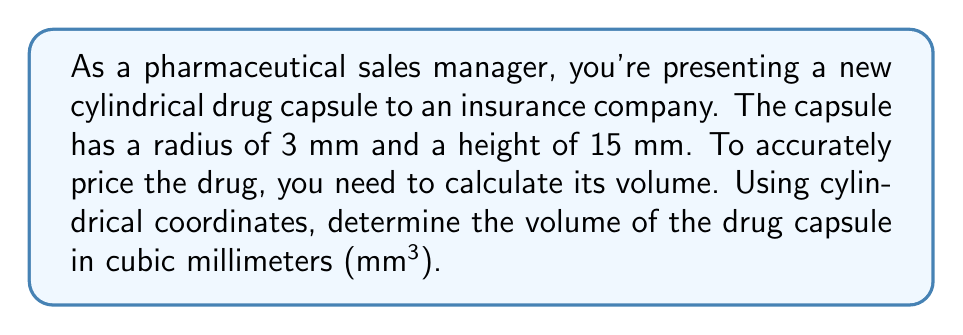Teach me how to tackle this problem. To calculate the volume of a cylindrical drug capsule using cylindrical coordinates, we'll follow these steps:

1) In cylindrical coordinates, a point is represented by $(r, \theta, z)$, where:
   - $r$ is the distance from the point to the z-axis
   - $\theta$ is the angle in the xy-plane from the positive x-axis
   - $z$ is the height above the xy-plane

2) The volume integral in cylindrical coordinates is given by:

   $$V = \iiint r \, dr \, d\theta \, dz$$

3) For our cylindrical capsule:
   - Radius (r) goes from 0 to 3 mm
   - Angle ($\theta$) goes from 0 to $2\pi$ radians
   - Height (z) goes from 0 to 15 mm

4) Set up the triple integral:

   $$V = \int_0^{15} \int_0^{2\pi} \int_0^3 r \, dr \, d\theta \, dz$$

5) Solve the innermost integral (with respect to r):

   $$V = \int_0^{15} \int_0^{2\pi} \left[\frac{r^2}{2}\right]_0^3 \, d\theta \, dz = \int_0^{15} \int_0^{2\pi} \frac{9}{2} \, d\theta \, dz$$

6) Solve the middle integral (with respect to $\theta$):

   $$V = \int_0^{15} \left[\frac{9}{2}\theta\right]_0^{2\pi} \, dz = \int_0^{15} 9\pi \, dz$$

7) Solve the outermost integral (with respect to z):

   $$V = [9\pi z]_0^{15} = 135\pi$$

8) The final volume is $135\pi$ cubic millimeters.
Answer: The volume of the cylindrical drug capsule is $135\pi$ mm³ or approximately 423.9 mm³. 